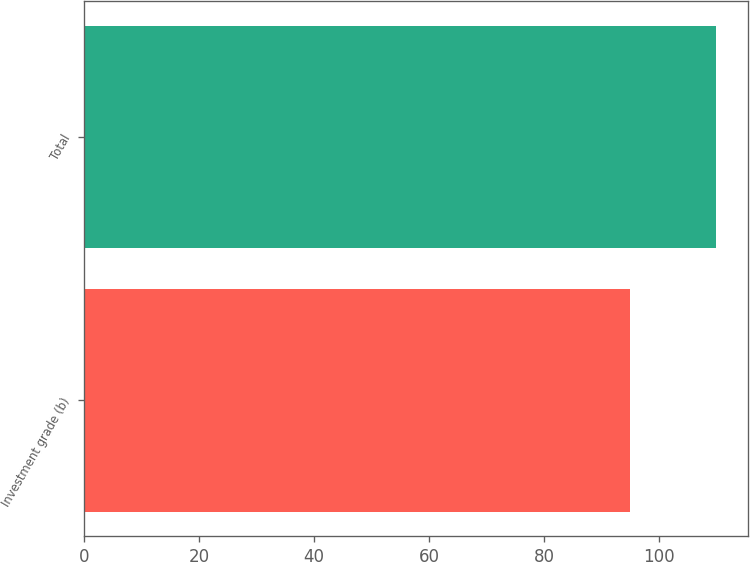Convert chart to OTSL. <chart><loc_0><loc_0><loc_500><loc_500><bar_chart><fcel>Investment grade (b)<fcel>Total<nl><fcel>95<fcel>110<nl></chart> 